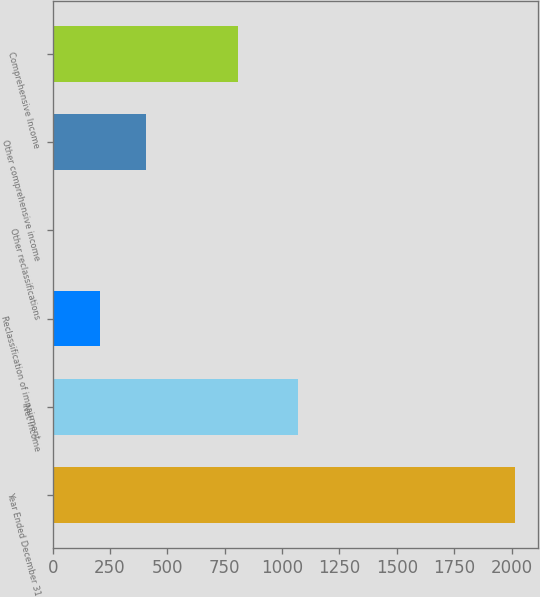<chart> <loc_0><loc_0><loc_500><loc_500><bar_chart><fcel>Year Ended December 31<fcel>Net income<fcel>Reclassification of impairment<fcel>Other reclassifications<fcel>Other comprehensive income<fcel>Comprehensive Income<nl><fcel>2013<fcel>1071<fcel>207.6<fcel>7<fcel>408.2<fcel>809.4<nl></chart> 